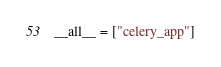<code> <loc_0><loc_0><loc_500><loc_500><_Python_>__all__ = ["celery_app"]
</code> 